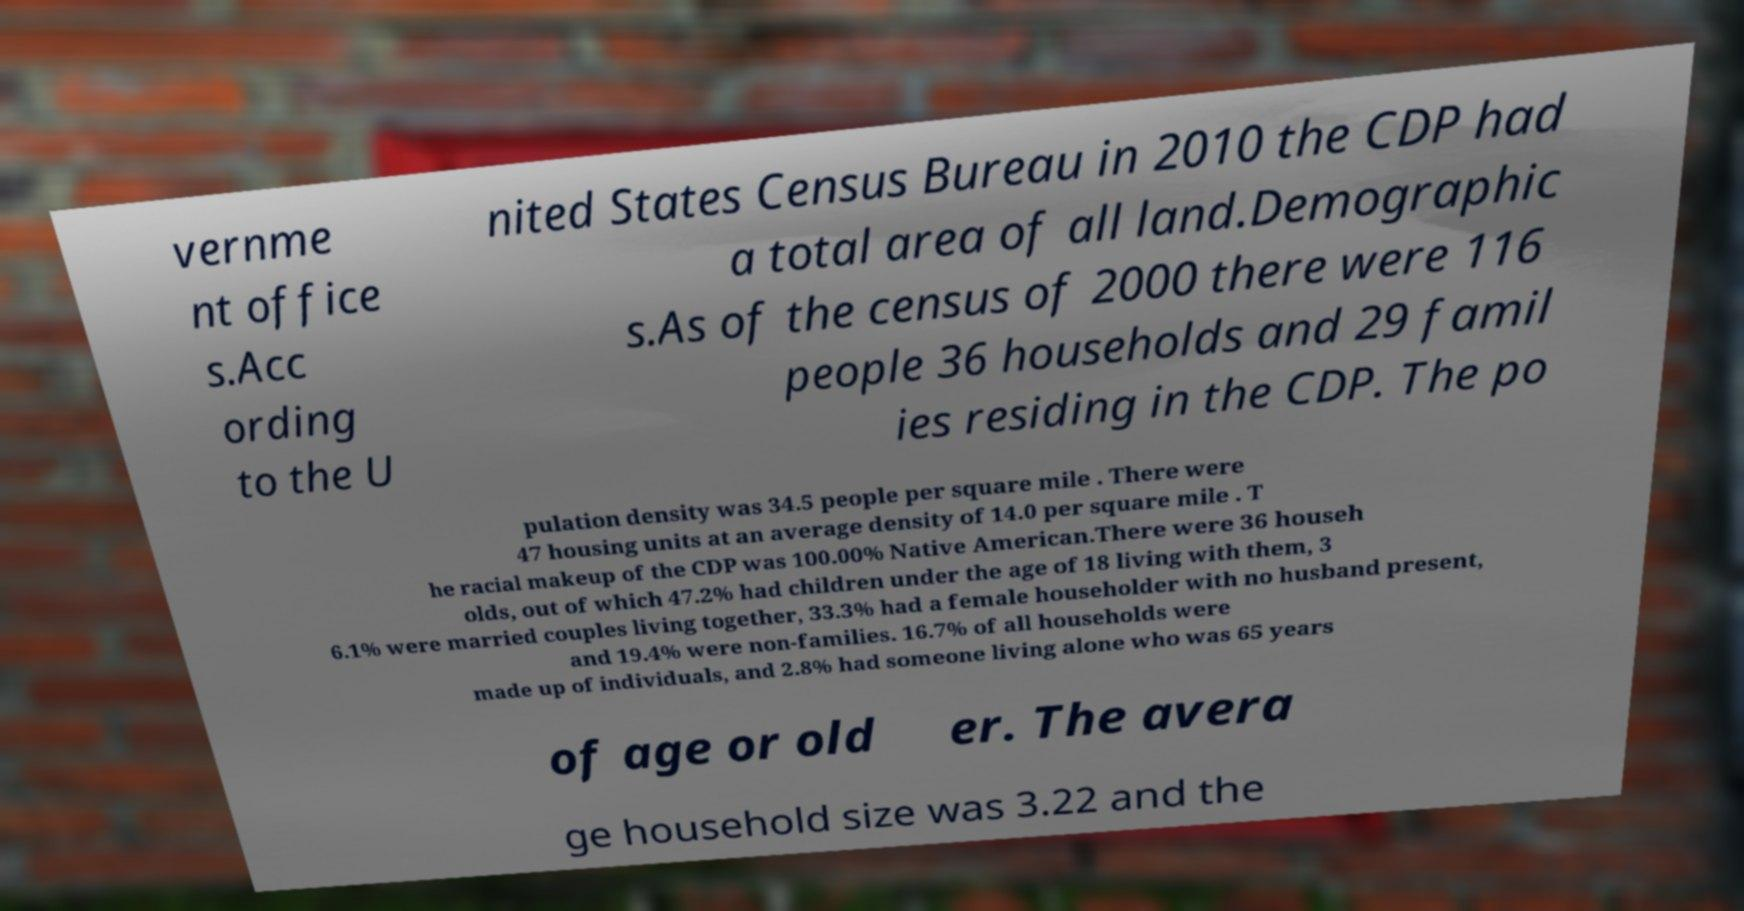For documentation purposes, I need the text within this image transcribed. Could you provide that? vernme nt office s.Acc ording to the U nited States Census Bureau in 2010 the CDP had a total area of all land.Demographic s.As of the census of 2000 there were 116 people 36 households and 29 famil ies residing in the CDP. The po pulation density was 34.5 people per square mile . There were 47 housing units at an average density of 14.0 per square mile . T he racial makeup of the CDP was 100.00% Native American.There were 36 househ olds, out of which 47.2% had children under the age of 18 living with them, 3 6.1% were married couples living together, 33.3% had a female householder with no husband present, and 19.4% were non-families. 16.7% of all households were made up of individuals, and 2.8% had someone living alone who was 65 years of age or old er. The avera ge household size was 3.22 and the 